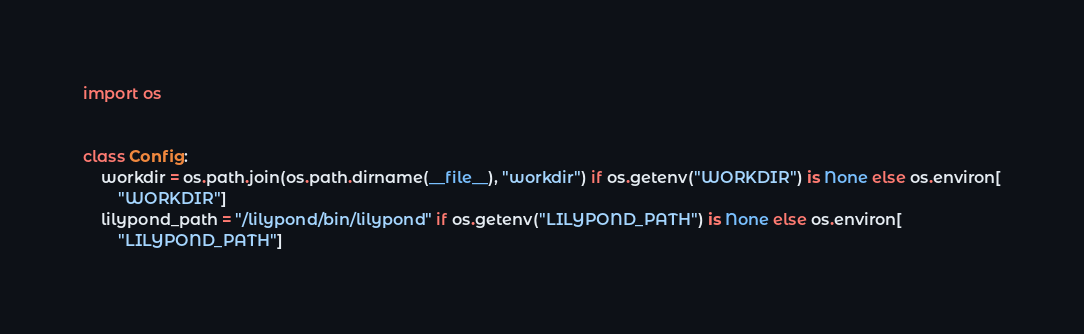<code> <loc_0><loc_0><loc_500><loc_500><_Python_>import os


class Config:
    workdir = os.path.join(os.path.dirname(__file__), "workdir") if os.getenv("WORKDIR") is None else os.environ[
        "WORKDIR"]
    lilypond_path = "/lilypond/bin/lilypond" if os.getenv("LILYPOND_PATH") is None else os.environ[
        "LILYPOND_PATH"]
</code> 